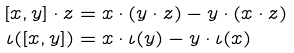Convert formula to latex. <formula><loc_0><loc_0><loc_500><loc_500>[ x , y ] \cdot z & = x \cdot ( y \cdot z ) - y \cdot ( x \cdot z ) \\ \iota ( [ x , y ] ) & = x \cdot \iota ( y ) - y \cdot \iota ( x )</formula> 